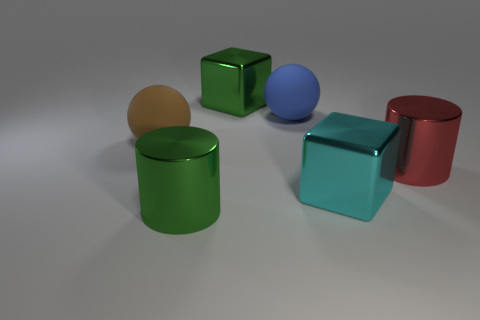Does the big green block have the same material as the green object in front of the cyan metal block?
Your response must be concise. Yes. What number of tiny objects are rubber balls or purple matte blocks?
Give a very brief answer. 0. Are there fewer objects than green rubber things?
Keep it short and to the point. No. Does the red shiny thing behind the big cyan metal object have the same size as the metal thing that is behind the brown matte object?
Ensure brevity in your answer.  Yes. How many brown things are either metal blocks or big rubber objects?
Your answer should be very brief. 1. Are there more blue things than small purple metallic objects?
Provide a succinct answer. Yes. How many things are either green metal things or large shiny things on the left side of the large red object?
Offer a very short reply. 3. How many other objects are there of the same shape as the large red thing?
Offer a terse response. 1. Is the number of large brown matte spheres that are to the right of the large cyan cube less than the number of big red cylinders that are to the right of the red metal cylinder?
Offer a terse response. No. Is there any other thing that has the same material as the big brown sphere?
Provide a succinct answer. Yes. 